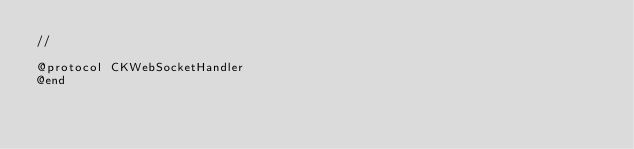<code> <loc_0><loc_0><loc_500><loc_500><_C_>//

@protocol CKWebSocketHandler
@end

</code> 